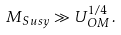<formula> <loc_0><loc_0><loc_500><loc_500>M _ { S u s y } \gg U _ { O M } ^ { 1 / 4 } \, .</formula> 